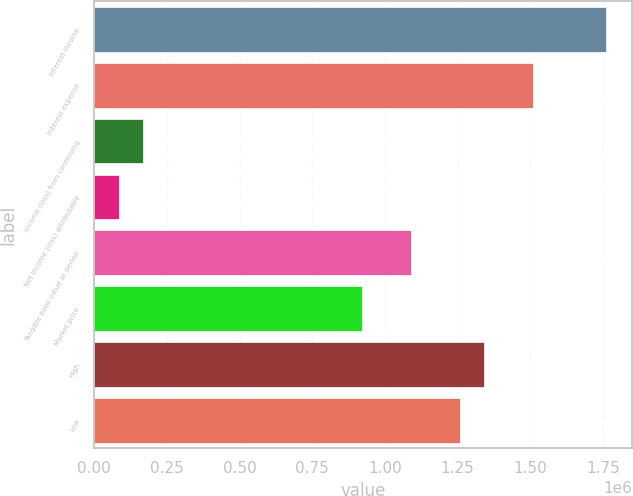<chart> <loc_0><loc_0><loc_500><loc_500><bar_chart><fcel>Interest income<fcel>Interest expense<fcel>Income (loss) from continuing<fcel>Net income (loss) attributable<fcel>Tangible book value at period<fcel>Market price<fcel>High<fcel>Low<nl><fcel>1.76165e+06<fcel>1.50998e+06<fcel>167776<fcel>83888.2<fcel>1.09054e+06<fcel>922768<fcel>1.34221e+06<fcel>1.25832e+06<nl></chart> 